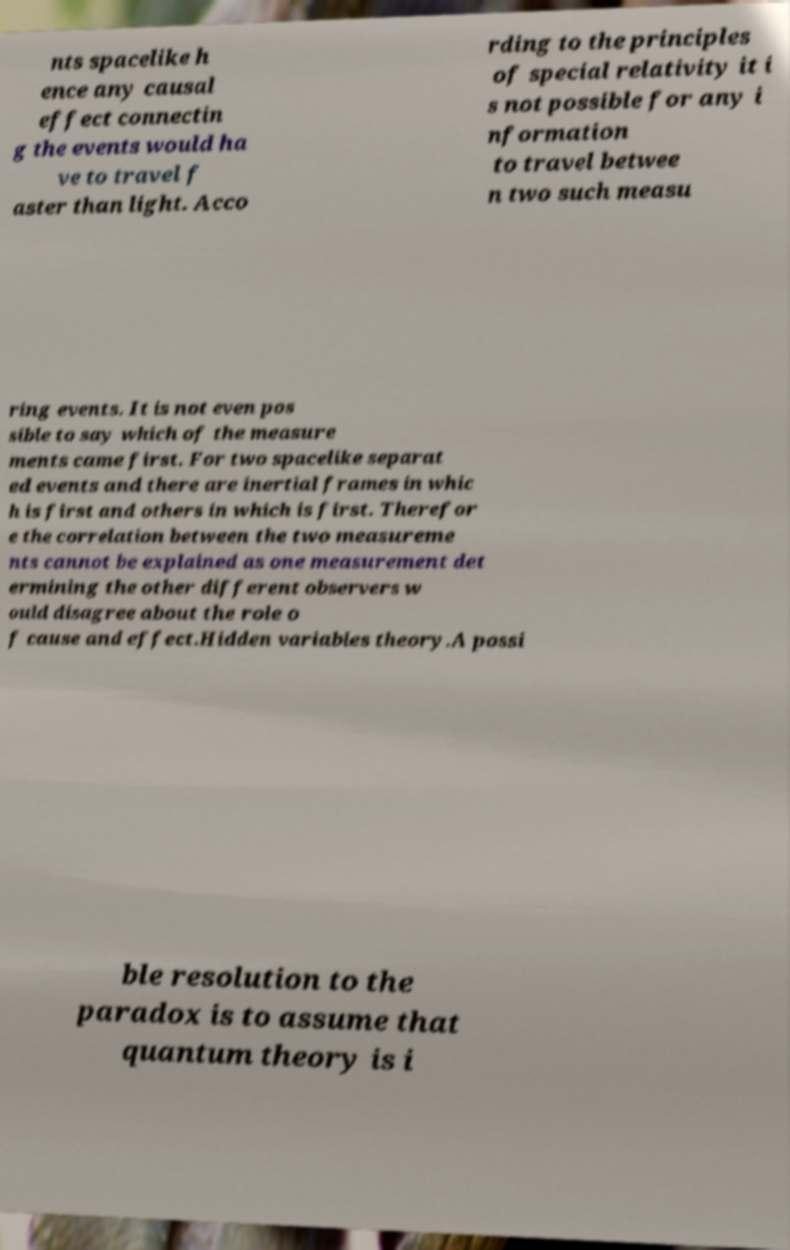For documentation purposes, I need the text within this image transcribed. Could you provide that? nts spacelike h ence any causal effect connectin g the events would ha ve to travel f aster than light. Acco rding to the principles of special relativity it i s not possible for any i nformation to travel betwee n two such measu ring events. It is not even pos sible to say which of the measure ments came first. For two spacelike separat ed events and there are inertial frames in whic h is first and others in which is first. Therefor e the correlation between the two measureme nts cannot be explained as one measurement det ermining the other different observers w ould disagree about the role o f cause and effect.Hidden variables theory.A possi ble resolution to the paradox is to assume that quantum theory is i 